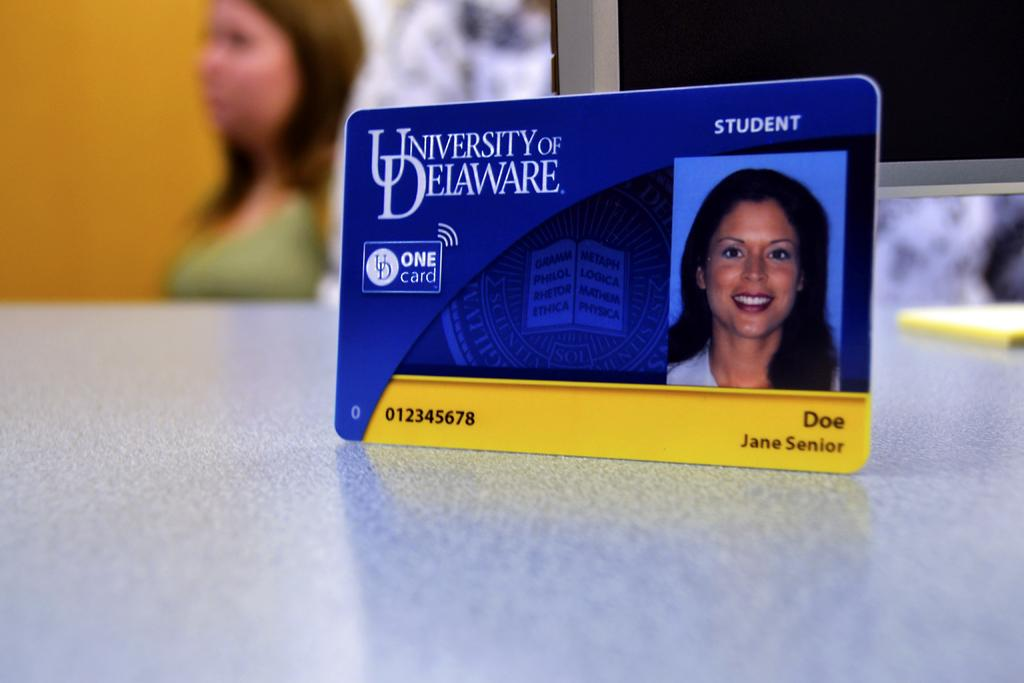What is placed on the table in the image? There is an ID card placed on a table. What can be seen on the right side of the image? There is an object on the right side of the image. Can you describe the background of the image? There is a person and a wall in the background of the image. What type of smoke can be seen coming from the ID card in the image? There is no smoke present in the image, as it features an ID card placed on a table. 